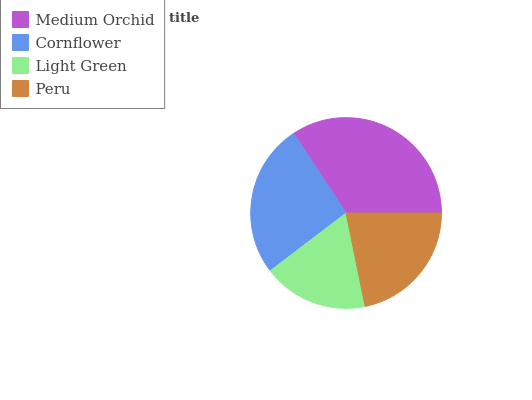Is Light Green the minimum?
Answer yes or no. Yes. Is Medium Orchid the maximum?
Answer yes or no. Yes. Is Cornflower the minimum?
Answer yes or no. No. Is Cornflower the maximum?
Answer yes or no. No. Is Medium Orchid greater than Cornflower?
Answer yes or no. Yes. Is Cornflower less than Medium Orchid?
Answer yes or no. Yes. Is Cornflower greater than Medium Orchid?
Answer yes or no. No. Is Medium Orchid less than Cornflower?
Answer yes or no. No. Is Cornflower the high median?
Answer yes or no. Yes. Is Peru the low median?
Answer yes or no. Yes. Is Peru the high median?
Answer yes or no. No. Is Cornflower the low median?
Answer yes or no. No. 